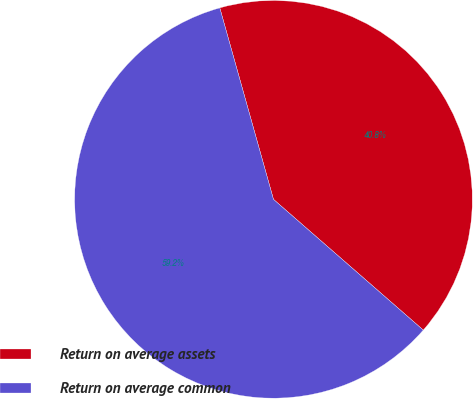<chart> <loc_0><loc_0><loc_500><loc_500><pie_chart><fcel>Return on average assets<fcel>Return on average common<nl><fcel>40.77%<fcel>59.23%<nl></chart> 